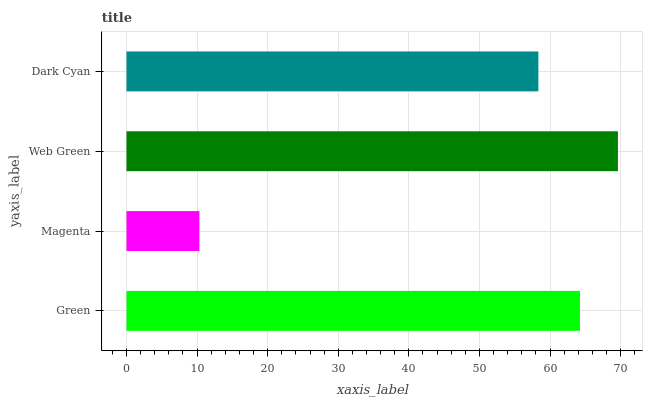Is Magenta the minimum?
Answer yes or no. Yes. Is Web Green the maximum?
Answer yes or no. Yes. Is Web Green the minimum?
Answer yes or no. No. Is Magenta the maximum?
Answer yes or no. No. Is Web Green greater than Magenta?
Answer yes or no. Yes. Is Magenta less than Web Green?
Answer yes or no. Yes. Is Magenta greater than Web Green?
Answer yes or no. No. Is Web Green less than Magenta?
Answer yes or no. No. Is Green the high median?
Answer yes or no. Yes. Is Dark Cyan the low median?
Answer yes or no. Yes. Is Magenta the high median?
Answer yes or no. No. Is Green the low median?
Answer yes or no. No. 